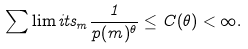Convert formula to latex. <formula><loc_0><loc_0><loc_500><loc_500>\sum \lim i t s _ { m } \frac { 1 } { p ( m ) ^ { \theta } } \leq C ( \theta ) < \infty .</formula> 